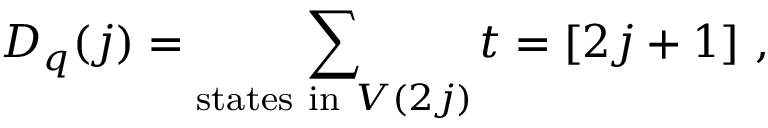<formula> <loc_0><loc_0><loc_500><loc_500>D _ { q } ( j ) = \sum _ { s t a t e s i n V ( 2 j ) } t = [ 2 j + 1 ] ,</formula> 